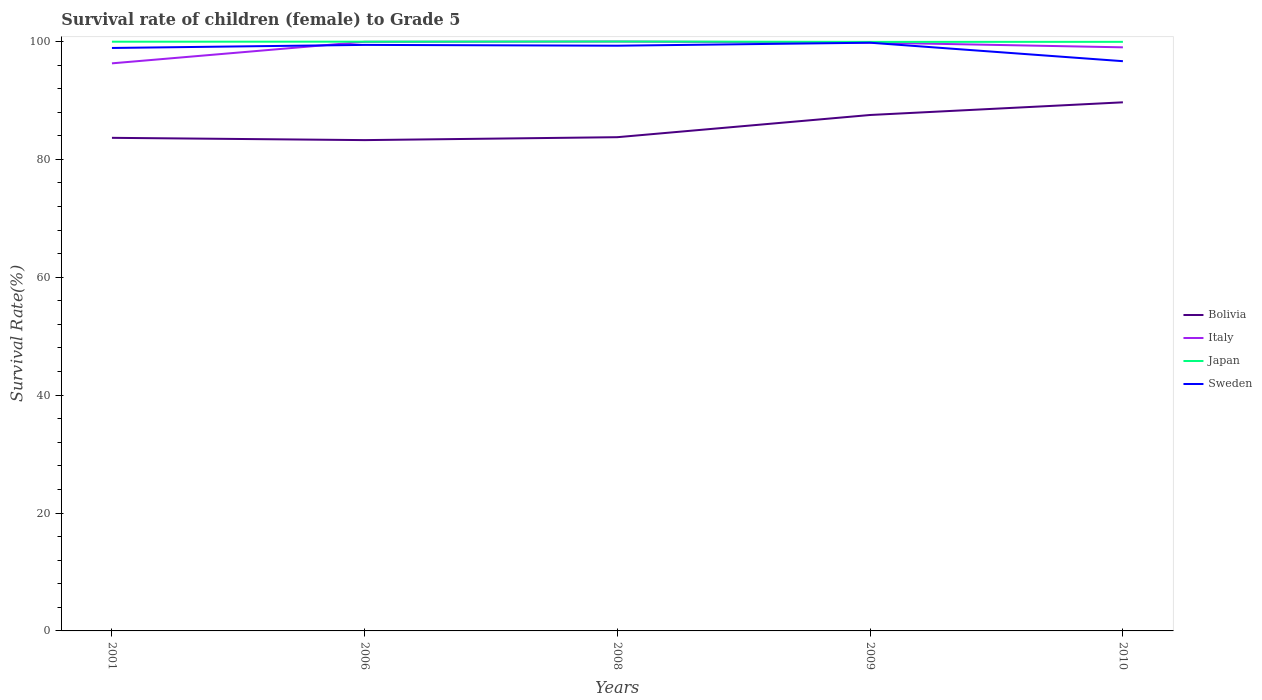How many different coloured lines are there?
Make the answer very short. 4. Does the line corresponding to Sweden intersect with the line corresponding to Bolivia?
Keep it short and to the point. No. Is the number of lines equal to the number of legend labels?
Provide a succinct answer. Yes. Across all years, what is the maximum survival rate of female children to grade 5 in Japan?
Give a very brief answer. 99.93. What is the total survival rate of female children to grade 5 in Japan in the graph?
Make the answer very short. 0.03. What is the difference between the highest and the second highest survival rate of female children to grade 5 in Bolivia?
Ensure brevity in your answer.  6.41. What is the difference between the highest and the lowest survival rate of female children to grade 5 in Sweden?
Your answer should be very brief. 4. Is the survival rate of female children to grade 5 in Japan strictly greater than the survival rate of female children to grade 5 in Sweden over the years?
Your answer should be very brief. No. What is the difference between two consecutive major ticks on the Y-axis?
Make the answer very short. 20. Are the values on the major ticks of Y-axis written in scientific E-notation?
Provide a succinct answer. No. Does the graph contain any zero values?
Provide a short and direct response. No. Does the graph contain grids?
Offer a terse response. No. Where does the legend appear in the graph?
Keep it short and to the point. Center right. How many legend labels are there?
Your response must be concise. 4. What is the title of the graph?
Your response must be concise. Survival rate of children (female) to Grade 5. What is the label or title of the X-axis?
Your answer should be very brief. Years. What is the label or title of the Y-axis?
Your answer should be compact. Survival Rate(%). What is the Survival Rate(%) of Bolivia in 2001?
Provide a succinct answer. 83.65. What is the Survival Rate(%) of Italy in 2001?
Your answer should be compact. 96.29. What is the Survival Rate(%) in Japan in 2001?
Offer a very short reply. 99.96. What is the Survival Rate(%) in Sweden in 2001?
Ensure brevity in your answer.  98.9. What is the Survival Rate(%) of Bolivia in 2006?
Your response must be concise. 83.26. What is the Survival Rate(%) in Italy in 2006?
Ensure brevity in your answer.  99.95. What is the Survival Rate(%) of Japan in 2006?
Your answer should be very brief. 99.97. What is the Survival Rate(%) of Sweden in 2006?
Provide a short and direct response. 99.42. What is the Survival Rate(%) of Bolivia in 2008?
Give a very brief answer. 83.76. What is the Survival Rate(%) of Italy in 2008?
Offer a very short reply. 99.99. What is the Survival Rate(%) of Japan in 2008?
Make the answer very short. 99.99. What is the Survival Rate(%) of Sweden in 2008?
Keep it short and to the point. 99.28. What is the Survival Rate(%) in Bolivia in 2009?
Give a very brief answer. 87.53. What is the Survival Rate(%) in Italy in 2009?
Make the answer very short. 99.82. What is the Survival Rate(%) in Japan in 2009?
Make the answer very short. 99.93. What is the Survival Rate(%) of Sweden in 2009?
Your response must be concise. 99.79. What is the Survival Rate(%) in Bolivia in 2010?
Your response must be concise. 89.68. What is the Survival Rate(%) in Italy in 2010?
Your answer should be very brief. 99.01. What is the Survival Rate(%) of Japan in 2010?
Ensure brevity in your answer.  99.94. What is the Survival Rate(%) in Sweden in 2010?
Your response must be concise. 96.65. Across all years, what is the maximum Survival Rate(%) of Bolivia?
Provide a short and direct response. 89.68. Across all years, what is the maximum Survival Rate(%) of Italy?
Your answer should be very brief. 99.99. Across all years, what is the maximum Survival Rate(%) of Japan?
Give a very brief answer. 99.99. Across all years, what is the maximum Survival Rate(%) of Sweden?
Offer a terse response. 99.79. Across all years, what is the minimum Survival Rate(%) of Bolivia?
Keep it short and to the point. 83.26. Across all years, what is the minimum Survival Rate(%) of Italy?
Keep it short and to the point. 96.29. Across all years, what is the minimum Survival Rate(%) of Japan?
Make the answer very short. 99.93. Across all years, what is the minimum Survival Rate(%) in Sweden?
Your answer should be very brief. 96.65. What is the total Survival Rate(%) in Bolivia in the graph?
Provide a succinct answer. 427.88. What is the total Survival Rate(%) of Italy in the graph?
Offer a very short reply. 495.04. What is the total Survival Rate(%) of Japan in the graph?
Give a very brief answer. 499.79. What is the total Survival Rate(%) of Sweden in the graph?
Make the answer very short. 494.04. What is the difference between the Survival Rate(%) of Bolivia in 2001 and that in 2006?
Your response must be concise. 0.39. What is the difference between the Survival Rate(%) of Italy in 2001 and that in 2006?
Provide a short and direct response. -3.66. What is the difference between the Survival Rate(%) in Japan in 2001 and that in 2006?
Offer a terse response. -0. What is the difference between the Survival Rate(%) in Sweden in 2001 and that in 2006?
Ensure brevity in your answer.  -0.52. What is the difference between the Survival Rate(%) in Bolivia in 2001 and that in 2008?
Ensure brevity in your answer.  -0.11. What is the difference between the Survival Rate(%) of Italy in 2001 and that in 2008?
Offer a terse response. -3.7. What is the difference between the Survival Rate(%) of Japan in 2001 and that in 2008?
Ensure brevity in your answer.  -0.03. What is the difference between the Survival Rate(%) of Sweden in 2001 and that in 2008?
Your answer should be very brief. -0.38. What is the difference between the Survival Rate(%) in Bolivia in 2001 and that in 2009?
Offer a very short reply. -3.88. What is the difference between the Survival Rate(%) of Italy in 2001 and that in 2009?
Ensure brevity in your answer.  -3.53. What is the difference between the Survival Rate(%) in Japan in 2001 and that in 2009?
Your response must be concise. 0.03. What is the difference between the Survival Rate(%) in Sweden in 2001 and that in 2009?
Your answer should be compact. -0.89. What is the difference between the Survival Rate(%) of Bolivia in 2001 and that in 2010?
Ensure brevity in your answer.  -6.02. What is the difference between the Survival Rate(%) in Italy in 2001 and that in 2010?
Provide a succinct answer. -2.72. What is the difference between the Survival Rate(%) of Japan in 2001 and that in 2010?
Make the answer very short. 0.03. What is the difference between the Survival Rate(%) in Sweden in 2001 and that in 2010?
Provide a succinct answer. 2.24. What is the difference between the Survival Rate(%) of Bolivia in 2006 and that in 2008?
Give a very brief answer. -0.5. What is the difference between the Survival Rate(%) of Italy in 2006 and that in 2008?
Keep it short and to the point. -0.04. What is the difference between the Survival Rate(%) of Japan in 2006 and that in 2008?
Your answer should be very brief. -0.03. What is the difference between the Survival Rate(%) in Sweden in 2006 and that in 2008?
Your answer should be very brief. 0.14. What is the difference between the Survival Rate(%) in Bolivia in 2006 and that in 2009?
Give a very brief answer. -4.26. What is the difference between the Survival Rate(%) in Italy in 2006 and that in 2009?
Your answer should be compact. 0.13. What is the difference between the Survival Rate(%) in Japan in 2006 and that in 2009?
Give a very brief answer. 0.03. What is the difference between the Survival Rate(%) in Sweden in 2006 and that in 2009?
Your answer should be compact. -0.37. What is the difference between the Survival Rate(%) of Bolivia in 2006 and that in 2010?
Make the answer very short. -6.41. What is the difference between the Survival Rate(%) of Italy in 2006 and that in 2010?
Give a very brief answer. 0.94. What is the difference between the Survival Rate(%) of Japan in 2006 and that in 2010?
Provide a succinct answer. 0.03. What is the difference between the Survival Rate(%) in Sweden in 2006 and that in 2010?
Provide a succinct answer. 2.76. What is the difference between the Survival Rate(%) in Bolivia in 2008 and that in 2009?
Provide a short and direct response. -3.77. What is the difference between the Survival Rate(%) in Italy in 2008 and that in 2009?
Provide a short and direct response. 0.17. What is the difference between the Survival Rate(%) in Japan in 2008 and that in 2009?
Provide a short and direct response. 0.06. What is the difference between the Survival Rate(%) in Sweden in 2008 and that in 2009?
Provide a short and direct response. -0.51. What is the difference between the Survival Rate(%) in Bolivia in 2008 and that in 2010?
Ensure brevity in your answer.  -5.91. What is the difference between the Survival Rate(%) in Italy in 2008 and that in 2010?
Provide a succinct answer. 0.98. What is the difference between the Survival Rate(%) in Japan in 2008 and that in 2010?
Your response must be concise. 0.06. What is the difference between the Survival Rate(%) of Sweden in 2008 and that in 2010?
Ensure brevity in your answer.  2.63. What is the difference between the Survival Rate(%) of Bolivia in 2009 and that in 2010?
Your answer should be compact. -2.15. What is the difference between the Survival Rate(%) of Italy in 2009 and that in 2010?
Offer a terse response. 0.81. What is the difference between the Survival Rate(%) in Japan in 2009 and that in 2010?
Ensure brevity in your answer.  -0. What is the difference between the Survival Rate(%) of Sweden in 2009 and that in 2010?
Ensure brevity in your answer.  3.13. What is the difference between the Survival Rate(%) of Bolivia in 2001 and the Survival Rate(%) of Italy in 2006?
Provide a short and direct response. -16.29. What is the difference between the Survival Rate(%) in Bolivia in 2001 and the Survival Rate(%) in Japan in 2006?
Offer a terse response. -16.31. What is the difference between the Survival Rate(%) of Bolivia in 2001 and the Survival Rate(%) of Sweden in 2006?
Ensure brevity in your answer.  -15.77. What is the difference between the Survival Rate(%) of Italy in 2001 and the Survival Rate(%) of Japan in 2006?
Give a very brief answer. -3.68. What is the difference between the Survival Rate(%) of Italy in 2001 and the Survival Rate(%) of Sweden in 2006?
Your answer should be compact. -3.13. What is the difference between the Survival Rate(%) in Japan in 2001 and the Survival Rate(%) in Sweden in 2006?
Your answer should be very brief. 0.54. What is the difference between the Survival Rate(%) of Bolivia in 2001 and the Survival Rate(%) of Italy in 2008?
Offer a very short reply. -16.33. What is the difference between the Survival Rate(%) in Bolivia in 2001 and the Survival Rate(%) in Japan in 2008?
Ensure brevity in your answer.  -16.34. What is the difference between the Survival Rate(%) in Bolivia in 2001 and the Survival Rate(%) in Sweden in 2008?
Provide a short and direct response. -15.63. What is the difference between the Survival Rate(%) of Italy in 2001 and the Survival Rate(%) of Japan in 2008?
Your answer should be very brief. -3.71. What is the difference between the Survival Rate(%) in Italy in 2001 and the Survival Rate(%) in Sweden in 2008?
Offer a terse response. -2.99. What is the difference between the Survival Rate(%) in Japan in 2001 and the Survival Rate(%) in Sweden in 2008?
Your answer should be compact. 0.68. What is the difference between the Survival Rate(%) in Bolivia in 2001 and the Survival Rate(%) in Italy in 2009?
Provide a short and direct response. -16.16. What is the difference between the Survival Rate(%) in Bolivia in 2001 and the Survival Rate(%) in Japan in 2009?
Offer a very short reply. -16.28. What is the difference between the Survival Rate(%) of Bolivia in 2001 and the Survival Rate(%) of Sweden in 2009?
Provide a short and direct response. -16.14. What is the difference between the Survival Rate(%) of Italy in 2001 and the Survival Rate(%) of Japan in 2009?
Make the answer very short. -3.64. What is the difference between the Survival Rate(%) of Italy in 2001 and the Survival Rate(%) of Sweden in 2009?
Provide a short and direct response. -3.5. What is the difference between the Survival Rate(%) of Japan in 2001 and the Survival Rate(%) of Sweden in 2009?
Provide a succinct answer. 0.17. What is the difference between the Survival Rate(%) of Bolivia in 2001 and the Survival Rate(%) of Italy in 2010?
Offer a terse response. -15.35. What is the difference between the Survival Rate(%) of Bolivia in 2001 and the Survival Rate(%) of Japan in 2010?
Ensure brevity in your answer.  -16.28. What is the difference between the Survival Rate(%) of Bolivia in 2001 and the Survival Rate(%) of Sweden in 2010?
Your answer should be compact. -13. What is the difference between the Survival Rate(%) in Italy in 2001 and the Survival Rate(%) in Japan in 2010?
Ensure brevity in your answer.  -3.65. What is the difference between the Survival Rate(%) in Italy in 2001 and the Survival Rate(%) in Sweden in 2010?
Make the answer very short. -0.37. What is the difference between the Survival Rate(%) of Japan in 2001 and the Survival Rate(%) of Sweden in 2010?
Your response must be concise. 3.31. What is the difference between the Survival Rate(%) of Bolivia in 2006 and the Survival Rate(%) of Italy in 2008?
Make the answer very short. -16.72. What is the difference between the Survival Rate(%) in Bolivia in 2006 and the Survival Rate(%) in Japan in 2008?
Give a very brief answer. -16.73. What is the difference between the Survival Rate(%) of Bolivia in 2006 and the Survival Rate(%) of Sweden in 2008?
Your answer should be compact. -16.02. What is the difference between the Survival Rate(%) in Italy in 2006 and the Survival Rate(%) in Japan in 2008?
Your response must be concise. -0.05. What is the difference between the Survival Rate(%) of Italy in 2006 and the Survival Rate(%) of Sweden in 2008?
Make the answer very short. 0.66. What is the difference between the Survival Rate(%) of Japan in 2006 and the Survival Rate(%) of Sweden in 2008?
Your response must be concise. 0.68. What is the difference between the Survival Rate(%) in Bolivia in 2006 and the Survival Rate(%) in Italy in 2009?
Offer a terse response. -16.55. What is the difference between the Survival Rate(%) of Bolivia in 2006 and the Survival Rate(%) of Japan in 2009?
Provide a succinct answer. -16.67. What is the difference between the Survival Rate(%) of Bolivia in 2006 and the Survival Rate(%) of Sweden in 2009?
Make the answer very short. -16.52. What is the difference between the Survival Rate(%) in Italy in 2006 and the Survival Rate(%) in Japan in 2009?
Your response must be concise. 0.01. What is the difference between the Survival Rate(%) in Italy in 2006 and the Survival Rate(%) in Sweden in 2009?
Ensure brevity in your answer.  0.16. What is the difference between the Survival Rate(%) in Japan in 2006 and the Survival Rate(%) in Sweden in 2009?
Provide a succinct answer. 0.18. What is the difference between the Survival Rate(%) of Bolivia in 2006 and the Survival Rate(%) of Italy in 2010?
Your answer should be compact. -15.74. What is the difference between the Survival Rate(%) in Bolivia in 2006 and the Survival Rate(%) in Japan in 2010?
Offer a very short reply. -16.67. What is the difference between the Survival Rate(%) in Bolivia in 2006 and the Survival Rate(%) in Sweden in 2010?
Ensure brevity in your answer.  -13.39. What is the difference between the Survival Rate(%) in Italy in 2006 and the Survival Rate(%) in Japan in 2010?
Your answer should be very brief. 0.01. What is the difference between the Survival Rate(%) of Italy in 2006 and the Survival Rate(%) of Sweden in 2010?
Offer a terse response. 3.29. What is the difference between the Survival Rate(%) of Japan in 2006 and the Survival Rate(%) of Sweden in 2010?
Provide a short and direct response. 3.31. What is the difference between the Survival Rate(%) in Bolivia in 2008 and the Survival Rate(%) in Italy in 2009?
Offer a terse response. -16.05. What is the difference between the Survival Rate(%) in Bolivia in 2008 and the Survival Rate(%) in Japan in 2009?
Offer a terse response. -16.17. What is the difference between the Survival Rate(%) of Bolivia in 2008 and the Survival Rate(%) of Sweden in 2009?
Keep it short and to the point. -16.03. What is the difference between the Survival Rate(%) in Italy in 2008 and the Survival Rate(%) in Japan in 2009?
Provide a short and direct response. 0.05. What is the difference between the Survival Rate(%) in Italy in 2008 and the Survival Rate(%) in Sweden in 2009?
Your answer should be compact. 0.2. What is the difference between the Survival Rate(%) of Japan in 2008 and the Survival Rate(%) of Sweden in 2009?
Offer a terse response. 0.2. What is the difference between the Survival Rate(%) of Bolivia in 2008 and the Survival Rate(%) of Italy in 2010?
Provide a short and direct response. -15.24. What is the difference between the Survival Rate(%) in Bolivia in 2008 and the Survival Rate(%) in Japan in 2010?
Your answer should be compact. -16.17. What is the difference between the Survival Rate(%) in Bolivia in 2008 and the Survival Rate(%) in Sweden in 2010?
Your response must be concise. -12.89. What is the difference between the Survival Rate(%) of Italy in 2008 and the Survival Rate(%) of Japan in 2010?
Your answer should be very brief. 0.05. What is the difference between the Survival Rate(%) in Italy in 2008 and the Survival Rate(%) in Sweden in 2010?
Ensure brevity in your answer.  3.33. What is the difference between the Survival Rate(%) of Japan in 2008 and the Survival Rate(%) of Sweden in 2010?
Offer a very short reply. 3.34. What is the difference between the Survival Rate(%) in Bolivia in 2009 and the Survival Rate(%) in Italy in 2010?
Make the answer very short. -11.48. What is the difference between the Survival Rate(%) of Bolivia in 2009 and the Survival Rate(%) of Japan in 2010?
Give a very brief answer. -12.41. What is the difference between the Survival Rate(%) in Bolivia in 2009 and the Survival Rate(%) in Sweden in 2010?
Ensure brevity in your answer.  -9.13. What is the difference between the Survival Rate(%) in Italy in 2009 and the Survival Rate(%) in Japan in 2010?
Give a very brief answer. -0.12. What is the difference between the Survival Rate(%) in Italy in 2009 and the Survival Rate(%) in Sweden in 2010?
Keep it short and to the point. 3.16. What is the difference between the Survival Rate(%) in Japan in 2009 and the Survival Rate(%) in Sweden in 2010?
Give a very brief answer. 3.28. What is the average Survival Rate(%) of Bolivia per year?
Your answer should be compact. 85.58. What is the average Survival Rate(%) in Italy per year?
Ensure brevity in your answer.  99.01. What is the average Survival Rate(%) in Japan per year?
Your answer should be compact. 99.96. What is the average Survival Rate(%) in Sweden per year?
Make the answer very short. 98.81. In the year 2001, what is the difference between the Survival Rate(%) of Bolivia and Survival Rate(%) of Italy?
Keep it short and to the point. -12.64. In the year 2001, what is the difference between the Survival Rate(%) in Bolivia and Survival Rate(%) in Japan?
Offer a terse response. -16.31. In the year 2001, what is the difference between the Survival Rate(%) of Bolivia and Survival Rate(%) of Sweden?
Offer a very short reply. -15.25. In the year 2001, what is the difference between the Survival Rate(%) of Italy and Survival Rate(%) of Japan?
Provide a short and direct response. -3.67. In the year 2001, what is the difference between the Survival Rate(%) of Italy and Survival Rate(%) of Sweden?
Offer a terse response. -2.61. In the year 2001, what is the difference between the Survival Rate(%) of Japan and Survival Rate(%) of Sweden?
Make the answer very short. 1.06. In the year 2006, what is the difference between the Survival Rate(%) in Bolivia and Survival Rate(%) in Italy?
Your answer should be compact. -16.68. In the year 2006, what is the difference between the Survival Rate(%) of Bolivia and Survival Rate(%) of Japan?
Make the answer very short. -16.7. In the year 2006, what is the difference between the Survival Rate(%) in Bolivia and Survival Rate(%) in Sweden?
Offer a very short reply. -16.15. In the year 2006, what is the difference between the Survival Rate(%) in Italy and Survival Rate(%) in Japan?
Your response must be concise. -0.02. In the year 2006, what is the difference between the Survival Rate(%) of Italy and Survival Rate(%) of Sweden?
Your answer should be compact. 0.53. In the year 2006, what is the difference between the Survival Rate(%) in Japan and Survival Rate(%) in Sweden?
Provide a short and direct response. 0.55. In the year 2008, what is the difference between the Survival Rate(%) in Bolivia and Survival Rate(%) in Italy?
Your response must be concise. -16.22. In the year 2008, what is the difference between the Survival Rate(%) in Bolivia and Survival Rate(%) in Japan?
Your response must be concise. -16.23. In the year 2008, what is the difference between the Survival Rate(%) of Bolivia and Survival Rate(%) of Sweden?
Keep it short and to the point. -15.52. In the year 2008, what is the difference between the Survival Rate(%) in Italy and Survival Rate(%) in Japan?
Ensure brevity in your answer.  -0.01. In the year 2008, what is the difference between the Survival Rate(%) of Italy and Survival Rate(%) of Sweden?
Offer a terse response. 0.71. In the year 2008, what is the difference between the Survival Rate(%) in Japan and Survival Rate(%) in Sweden?
Offer a terse response. 0.71. In the year 2009, what is the difference between the Survival Rate(%) of Bolivia and Survival Rate(%) of Italy?
Offer a very short reply. -12.29. In the year 2009, what is the difference between the Survival Rate(%) in Bolivia and Survival Rate(%) in Japan?
Make the answer very short. -12.4. In the year 2009, what is the difference between the Survival Rate(%) in Bolivia and Survival Rate(%) in Sweden?
Give a very brief answer. -12.26. In the year 2009, what is the difference between the Survival Rate(%) of Italy and Survival Rate(%) of Japan?
Your response must be concise. -0.11. In the year 2009, what is the difference between the Survival Rate(%) in Italy and Survival Rate(%) in Sweden?
Your answer should be very brief. 0.03. In the year 2009, what is the difference between the Survival Rate(%) in Japan and Survival Rate(%) in Sweden?
Offer a very short reply. 0.14. In the year 2010, what is the difference between the Survival Rate(%) of Bolivia and Survival Rate(%) of Italy?
Offer a terse response. -9.33. In the year 2010, what is the difference between the Survival Rate(%) in Bolivia and Survival Rate(%) in Japan?
Ensure brevity in your answer.  -10.26. In the year 2010, what is the difference between the Survival Rate(%) in Bolivia and Survival Rate(%) in Sweden?
Offer a very short reply. -6.98. In the year 2010, what is the difference between the Survival Rate(%) in Italy and Survival Rate(%) in Japan?
Make the answer very short. -0.93. In the year 2010, what is the difference between the Survival Rate(%) in Italy and Survival Rate(%) in Sweden?
Provide a short and direct response. 2.35. In the year 2010, what is the difference between the Survival Rate(%) of Japan and Survival Rate(%) of Sweden?
Keep it short and to the point. 3.28. What is the ratio of the Survival Rate(%) of Italy in 2001 to that in 2006?
Your response must be concise. 0.96. What is the ratio of the Survival Rate(%) in Bolivia in 2001 to that in 2008?
Your answer should be compact. 1. What is the ratio of the Survival Rate(%) of Italy in 2001 to that in 2008?
Your answer should be compact. 0.96. What is the ratio of the Survival Rate(%) in Bolivia in 2001 to that in 2009?
Ensure brevity in your answer.  0.96. What is the ratio of the Survival Rate(%) in Italy in 2001 to that in 2009?
Your answer should be very brief. 0.96. What is the ratio of the Survival Rate(%) of Sweden in 2001 to that in 2009?
Give a very brief answer. 0.99. What is the ratio of the Survival Rate(%) in Bolivia in 2001 to that in 2010?
Ensure brevity in your answer.  0.93. What is the ratio of the Survival Rate(%) of Italy in 2001 to that in 2010?
Ensure brevity in your answer.  0.97. What is the ratio of the Survival Rate(%) in Japan in 2001 to that in 2010?
Give a very brief answer. 1. What is the ratio of the Survival Rate(%) of Sweden in 2001 to that in 2010?
Ensure brevity in your answer.  1.02. What is the ratio of the Survival Rate(%) of Italy in 2006 to that in 2008?
Offer a terse response. 1. What is the ratio of the Survival Rate(%) of Bolivia in 2006 to that in 2009?
Offer a very short reply. 0.95. What is the ratio of the Survival Rate(%) in Italy in 2006 to that in 2009?
Your answer should be very brief. 1. What is the ratio of the Survival Rate(%) of Japan in 2006 to that in 2009?
Offer a terse response. 1. What is the ratio of the Survival Rate(%) in Sweden in 2006 to that in 2009?
Your answer should be compact. 1. What is the ratio of the Survival Rate(%) in Bolivia in 2006 to that in 2010?
Your answer should be very brief. 0.93. What is the ratio of the Survival Rate(%) in Italy in 2006 to that in 2010?
Give a very brief answer. 1.01. What is the ratio of the Survival Rate(%) of Japan in 2006 to that in 2010?
Keep it short and to the point. 1. What is the ratio of the Survival Rate(%) of Sweden in 2006 to that in 2010?
Your response must be concise. 1.03. What is the ratio of the Survival Rate(%) in Bolivia in 2008 to that in 2009?
Offer a terse response. 0.96. What is the ratio of the Survival Rate(%) of Italy in 2008 to that in 2009?
Provide a short and direct response. 1. What is the ratio of the Survival Rate(%) in Bolivia in 2008 to that in 2010?
Provide a succinct answer. 0.93. What is the ratio of the Survival Rate(%) in Italy in 2008 to that in 2010?
Make the answer very short. 1.01. What is the ratio of the Survival Rate(%) in Sweden in 2008 to that in 2010?
Give a very brief answer. 1.03. What is the ratio of the Survival Rate(%) of Italy in 2009 to that in 2010?
Provide a succinct answer. 1.01. What is the ratio of the Survival Rate(%) in Japan in 2009 to that in 2010?
Offer a very short reply. 1. What is the ratio of the Survival Rate(%) of Sweden in 2009 to that in 2010?
Your answer should be compact. 1.03. What is the difference between the highest and the second highest Survival Rate(%) of Bolivia?
Keep it short and to the point. 2.15. What is the difference between the highest and the second highest Survival Rate(%) in Italy?
Provide a short and direct response. 0.04. What is the difference between the highest and the second highest Survival Rate(%) in Japan?
Provide a succinct answer. 0.03. What is the difference between the highest and the second highest Survival Rate(%) in Sweden?
Offer a terse response. 0.37. What is the difference between the highest and the lowest Survival Rate(%) in Bolivia?
Your answer should be compact. 6.41. What is the difference between the highest and the lowest Survival Rate(%) of Italy?
Your answer should be very brief. 3.7. What is the difference between the highest and the lowest Survival Rate(%) of Japan?
Offer a terse response. 0.06. What is the difference between the highest and the lowest Survival Rate(%) of Sweden?
Your answer should be very brief. 3.13. 